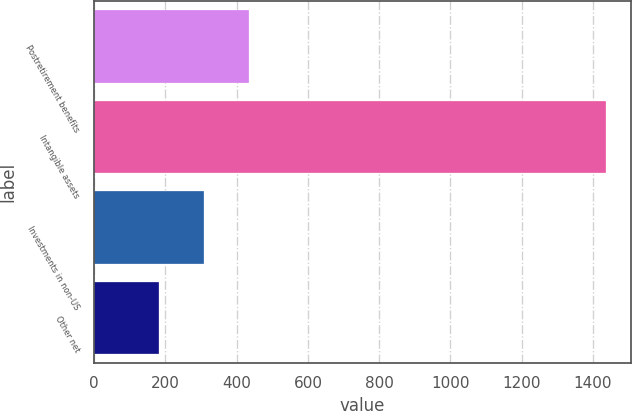<chart> <loc_0><loc_0><loc_500><loc_500><bar_chart><fcel>Postretirement benefits<fcel>Intangible assets<fcel>Investments in non-US<fcel>Other net<nl><fcel>433.4<fcel>1435<fcel>308.2<fcel>183<nl></chart> 